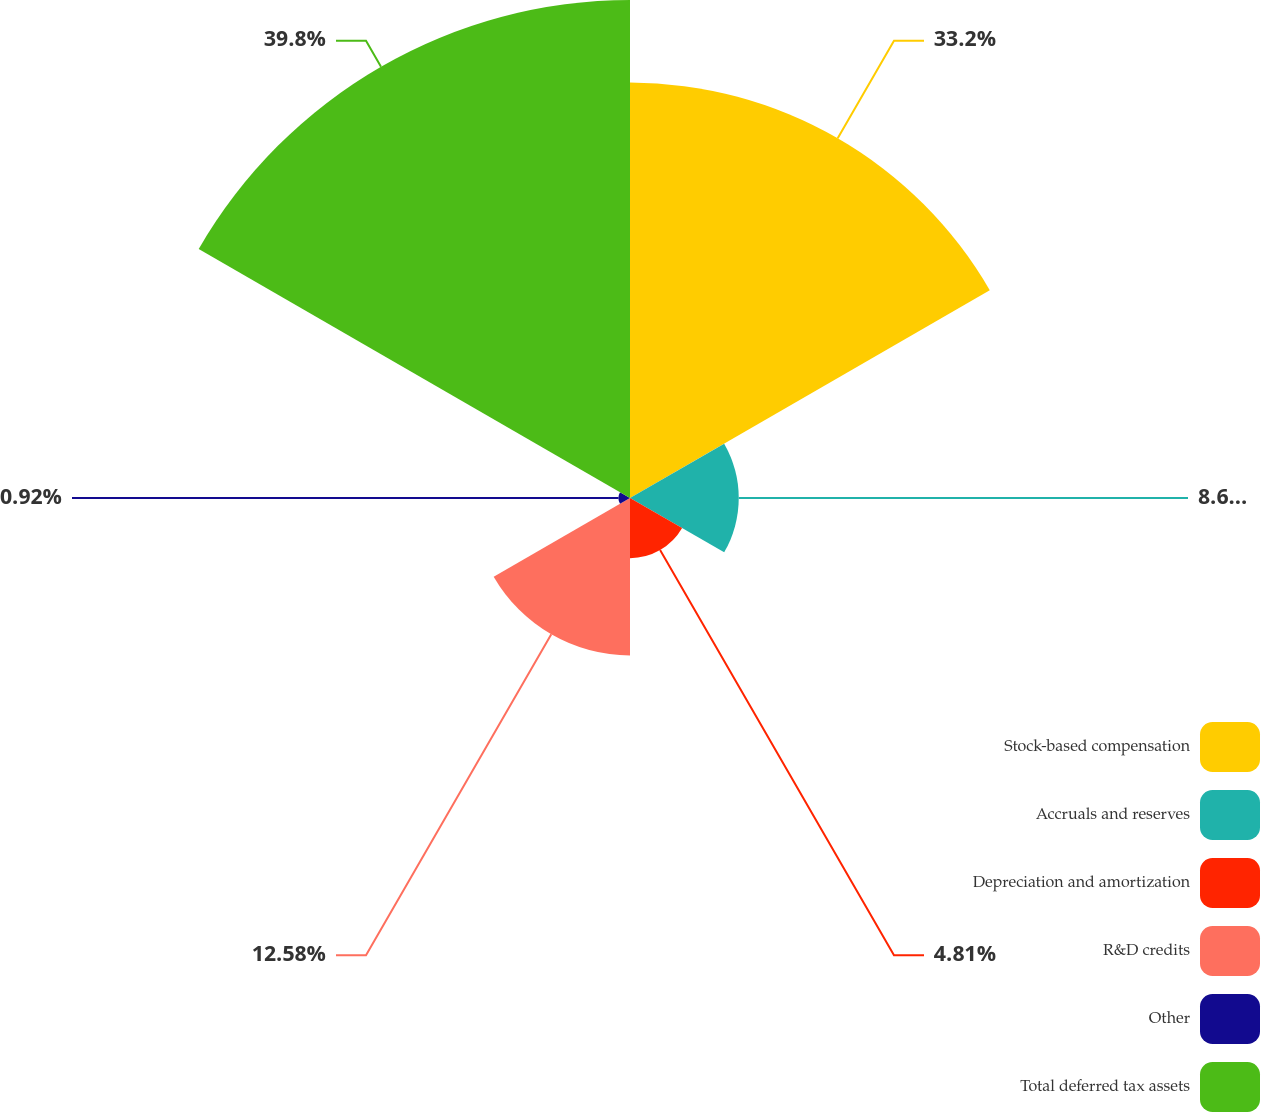<chart> <loc_0><loc_0><loc_500><loc_500><pie_chart><fcel>Stock-based compensation<fcel>Accruals and reserves<fcel>Depreciation and amortization<fcel>R&D credits<fcel>Other<fcel>Total deferred tax assets<nl><fcel>33.2%<fcel>8.69%<fcel>4.81%<fcel>12.58%<fcel>0.92%<fcel>39.8%<nl></chart> 